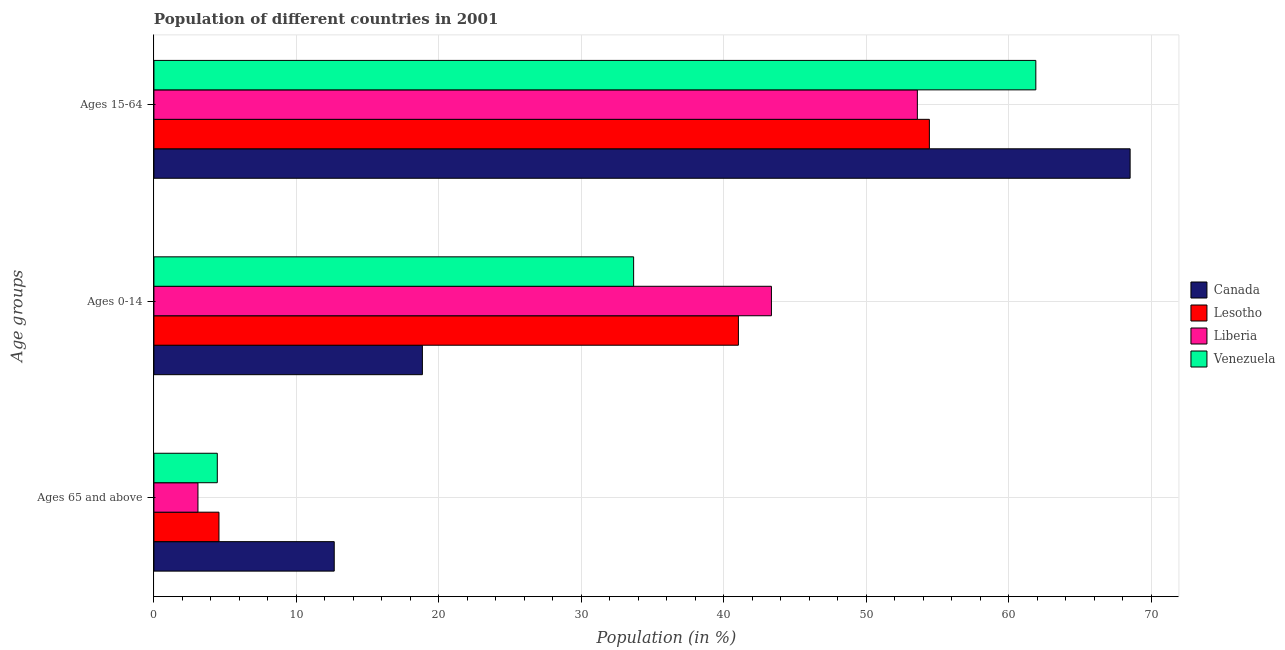Are the number of bars on each tick of the Y-axis equal?
Provide a short and direct response. Yes. How many bars are there on the 3rd tick from the top?
Provide a succinct answer. 4. What is the label of the 2nd group of bars from the top?
Your response must be concise. Ages 0-14. What is the percentage of population within the age-group 15-64 in Lesotho?
Provide a short and direct response. 54.42. Across all countries, what is the maximum percentage of population within the age-group 15-64?
Your answer should be compact. 68.51. Across all countries, what is the minimum percentage of population within the age-group of 65 and above?
Your answer should be compact. 3.09. In which country was the percentage of population within the age-group 15-64 minimum?
Ensure brevity in your answer.  Liberia. What is the total percentage of population within the age-group 0-14 in the graph?
Make the answer very short. 136.85. What is the difference between the percentage of population within the age-group 15-64 in Lesotho and that in Canada?
Your answer should be compact. -14.09. What is the difference between the percentage of population within the age-group 0-14 in Liberia and the percentage of population within the age-group of 65 and above in Venezuela?
Ensure brevity in your answer.  38.89. What is the average percentage of population within the age-group 15-64 per country?
Your answer should be very brief. 59.6. What is the difference between the percentage of population within the age-group of 65 and above and percentage of population within the age-group 0-14 in Liberia?
Provide a short and direct response. -40.24. In how many countries, is the percentage of population within the age-group 0-14 greater than 46 %?
Provide a succinct answer. 0. What is the ratio of the percentage of population within the age-group of 65 and above in Liberia to that in Lesotho?
Offer a terse response. 0.68. Is the percentage of population within the age-group 15-64 in Venezuela less than that in Lesotho?
Offer a very short reply. No. Is the difference between the percentage of population within the age-group of 65 and above in Canada and Venezuela greater than the difference between the percentage of population within the age-group 0-14 in Canada and Venezuela?
Offer a terse response. Yes. What is the difference between the highest and the second highest percentage of population within the age-group 15-64?
Make the answer very short. 6.62. What is the difference between the highest and the lowest percentage of population within the age-group 15-64?
Your answer should be very brief. 14.93. In how many countries, is the percentage of population within the age-group 0-14 greater than the average percentage of population within the age-group 0-14 taken over all countries?
Provide a succinct answer. 2. Is the sum of the percentage of population within the age-group 15-64 in Lesotho and Venezuela greater than the maximum percentage of population within the age-group 0-14 across all countries?
Ensure brevity in your answer.  Yes. What does the 1st bar from the top in Ages 0-14 represents?
Keep it short and to the point. Venezuela. What does the 1st bar from the bottom in Ages 0-14 represents?
Your answer should be compact. Canada. Is it the case that in every country, the sum of the percentage of population within the age-group of 65 and above and percentage of population within the age-group 0-14 is greater than the percentage of population within the age-group 15-64?
Offer a terse response. No. Are all the bars in the graph horizontal?
Your answer should be compact. Yes. What is the difference between two consecutive major ticks on the X-axis?
Offer a terse response. 10. Does the graph contain any zero values?
Ensure brevity in your answer.  No. How are the legend labels stacked?
Ensure brevity in your answer.  Vertical. What is the title of the graph?
Give a very brief answer. Population of different countries in 2001. What is the label or title of the Y-axis?
Make the answer very short. Age groups. What is the Population (in %) of Canada in Ages 65 and above?
Keep it short and to the point. 12.65. What is the Population (in %) of Lesotho in Ages 65 and above?
Offer a terse response. 4.56. What is the Population (in %) in Liberia in Ages 65 and above?
Your answer should be compact. 3.09. What is the Population (in %) in Venezuela in Ages 65 and above?
Your answer should be compact. 4.45. What is the Population (in %) in Canada in Ages 0-14?
Offer a very short reply. 18.84. What is the Population (in %) in Lesotho in Ages 0-14?
Your answer should be very brief. 41.02. What is the Population (in %) of Liberia in Ages 0-14?
Keep it short and to the point. 43.33. What is the Population (in %) of Venezuela in Ages 0-14?
Provide a succinct answer. 33.66. What is the Population (in %) in Canada in Ages 15-64?
Your response must be concise. 68.51. What is the Population (in %) of Lesotho in Ages 15-64?
Your answer should be compact. 54.42. What is the Population (in %) in Liberia in Ages 15-64?
Your answer should be very brief. 53.58. What is the Population (in %) in Venezuela in Ages 15-64?
Your answer should be compact. 61.89. Across all Age groups, what is the maximum Population (in %) of Canada?
Provide a succinct answer. 68.51. Across all Age groups, what is the maximum Population (in %) of Lesotho?
Ensure brevity in your answer.  54.42. Across all Age groups, what is the maximum Population (in %) in Liberia?
Give a very brief answer. 53.58. Across all Age groups, what is the maximum Population (in %) of Venezuela?
Your answer should be compact. 61.89. Across all Age groups, what is the minimum Population (in %) of Canada?
Offer a very short reply. 12.65. Across all Age groups, what is the minimum Population (in %) in Lesotho?
Give a very brief answer. 4.56. Across all Age groups, what is the minimum Population (in %) of Liberia?
Offer a very short reply. 3.09. Across all Age groups, what is the minimum Population (in %) in Venezuela?
Offer a very short reply. 4.45. What is the total Population (in %) in Canada in the graph?
Ensure brevity in your answer.  100. What is the total Population (in %) of Lesotho in the graph?
Your answer should be compact. 100. What is the total Population (in %) of Liberia in the graph?
Your answer should be very brief. 100. What is the total Population (in %) of Venezuela in the graph?
Offer a terse response. 100. What is the difference between the Population (in %) of Canada in Ages 65 and above and that in Ages 0-14?
Make the answer very short. -6.19. What is the difference between the Population (in %) of Lesotho in Ages 65 and above and that in Ages 0-14?
Offer a very short reply. -36.45. What is the difference between the Population (in %) in Liberia in Ages 65 and above and that in Ages 0-14?
Your answer should be very brief. -40.24. What is the difference between the Population (in %) of Venezuela in Ages 65 and above and that in Ages 0-14?
Provide a succinct answer. -29.22. What is the difference between the Population (in %) of Canada in Ages 65 and above and that in Ages 15-64?
Make the answer very short. -55.85. What is the difference between the Population (in %) of Lesotho in Ages 65 and above and that in Ages 15-64?
Give a very brief answer. -49.85. What is the difference between the Population (in %) in Liberia in Ages 65 and above and that in Ages 15-64?
Provide a succinct answer. -50.49. What is the difference between the Population (in %) of Venezuela in Ages 65 and above and that in Ages 15-64?
Give a very brief answer. -57.44. What is the difference between the Population (in %) in Canada in Ages 0-14 and that in Ages 15-64?
Ensure brevity in your answer.  -49.67. What is the difference between the Population (in %) in Lesotho in Ages 0-14 and that in Ages 15-64?
Your answer should be very brief. -13.4. What is the difference between the Population (in %) of Liberia in Ages 0-14 and that in Ages 15-64?
Your answer should be compact. -10.24. What is the difference between the Population (in %) in Venezuela in Ages 0-14 and that in Ages 15-64?
Your answer should be very brief. -28.23. What is the difference between the Population (in %) in Canada in Ages 65 and above and the Population (in %) in Lesotho in Ages 0-14?
Your answer should be very brief. -28.36. What is the difference between the Population (in %) of Canada in Ages 65 and above and the Population (in %) of Liberia in Ages 0-14?
Your answer should be very brief. -30.68. What is the difference between the Population (in %) in Canada in Ages 65 and above and the Population (in %) in Venezuela in Ages 0-14?
Give a very brief answer. -21.01. What is the difference between the Population (in %) in Lesotho in Ages 65 and above and the Population (in %) in Liberia in Ages 0-14?
Offer a terse response. -38.77. What is the difference between the Population (in %) in Lesotho in Ages 65 and above and the Population (in %) in Venezuela in Ages 0-14?
Provide a short and direct response. -29.1. What is the difference between the Population (in %) in Liberia in Ages 65 and above and the Population (in %) in Venezuela in Ages 0-14?
Provide a succinct answer. -30.57. What is the difference between the Population (in %) in Canada in Ages 65 and above and the Population (in %) in Lesotho in Ages 15-64?
Your answer should be compact. -41.77. What is the difference between the Population (in %) in Canada in Ages 65 and above and the Population (in %) in Liberia in Ages 15-64?
Provide a short and direct response. -40.92. What is the difference between the Population (in %) in Canada in Ages 65 and above and the Population (in %) in Venezuela in Ages 15-64?
Your answer should be compact. -49.24. What is the difference between the Population (in %) of Lesotho in Ages 65 and above and the Population (in %) of Liberia in Ages 15-64?
Ensure brevity in your answer.  -49.01. What is the difference between the Population (in %) of Lesotho in Ages 65 and above and the Population (in %) of Venezuela in Ages 15-64?
Give a very brief answer. -57.33. What is the difference between the Population (in %) of Liberia in Ages 65 and above and the Population (in %) of Venezuela in Ages 15-64?
Ensure brevity in your answer.  -58.8. What is the difference between the Population (in %) of Canada in Ages 0-14 and the Population (in %) of Lesotho in Ages 15-64?
Keep it short and to the point. -35.58. What is the difference between the Population (in %) in Canada in Ages 0-14 and the Population (in %) in Liberia in Ages 15-64?
Your response must be concise. -34.74. What is the difference between the Population (in %) in Canada in Ages 0-14 and the Population (in %) in Venezuela in Ages 15-64?
Make the answer very short. -43.05. What is the difference between the Population (in %) of Lesotho in Ages 0-14 and the Population (in %) of Liberia in Ages 15-64?
Your answer should be very brief. -12.56. What is the difference between the Population (in %) of Lesotho in Ages 0-14 and the Population (in %) of Venezuela in Ages 15-64?
Provide a short and direct response. -20.87. What is the difference between the Population (in %) in Liberia in Ages 0-14 and the Population (in %) in Venezuela in Ages 15-64?
Provide a short and direct response. -18.56. What is the average Population (in %) in Canada per Age groups?
Your response must be concise. 33.33. What is the average Population (in %) in Lesotho per Age groups?
Provide a succinct answer. 33.33. What is the average Population (in %) of Liberia per Age groups?
Keep it short and to the point. 33.33. What is the average Population (in %) in Venezuela per Age groups?
Make the answer very short. 33.33. What is the difference between the Population (in %) of Canada and Population (in %) of Lesotho in Ages 65 and above?
Offer a terse response. 8.09. What is the difference between the Population (in %) of Canada and Population (in %) of Liberia in Ages 65 and above?
Provide a short and direct response. 9.56. What is the difference between the Population (in %) in Canada and Population (in %) in Venezuela in Ages 65 and above?
Ensure brevity in your answer.  8.21. What is the difference between the Population (in %) in Lesotho and Population (in %) in Liberia in Ages 65 and above?
Ensure brevity in your answer.  1.47. What is the difference between the Population (in %) of Lesotho and Population (in %) of Venezuela in Ages 65 and above?
Make the answer very short. 0.12. What is the difference between the Population (in %) in Liberia and Population (in %) in Venezuela in Ages 65 and above?
Provide a short and direct response. -1.36. What is the difference between the Population (in %) in Canada and Population (in %) in Lesotho in Ages 0-14?
Your response must be concise. -22.18. What is the difference between the Population (in %) of Canada and Population (in %) of Liberia in Ages 0-14?
Your response must be concise. -24.49. What is the difference between the Population (in %) in Canada and Population (in %) in Venezuela in Ages 0-14?
Offer a terse response. -14.82. What is the difference between the Population (in %) of Lesotho and Population (in %) of Liberia in Ages 0-14?
Your answer should be compact. -2.32. What is the difference between the Population (in %) in Lesotho and Population (in %) in Venezuela in Ages 0-14?
Offer a terse response. 7.35. What is the difference between the Population (in %) of Liberia and Population (in %) of Venezuela in Ages 0-14?
Offer a very short reply. 9.67. What is the difference between the Population (in %) of Canada and Population (in %) of Lesotho in Ages 15-64?
Give a very brief answer. 14.09. What is the difference between the Population (in %) in Canada and Population (in %) in Liberia in Ages 15-64?
Provide a succinct answer. 14.93. What is the difference between the Population (in %) of Canada and Population (in %) of Venezuela in Ages 15-64?
Your answer should be compact. 6.62. What is the difference between the Population (in %) of Lesotho and Population (in %) of Liberia in Ages 15-64?
Offer a terse response. 0.84. What is the difference between the Population (in %) of Lesotho and Population (in %) of Venezuela in Ages 15-64?
Offer a very short reply. -7.47. What is the difference between the Population (in %) of Liberia and Population (in %) of Venezuela in Ages 15-64?
Give a very brief answer. -8.31. What is the ratio of the Population (in %) of Canada in Ages 65 and above to that in Ages 0-14?
Give a very brief answer. 0.67. What is the ratio of the Population (in %) in Lesotho in Ages 65 and above to that in Ages 0-14?
Your answer should be very brief. 0.11. What is the ratio of the Population (in %) of Liberia in Ages 65 and above to that in Ages 0-14?
Ensure brevity in your answer.  0.07. What is the ratio of the Population (in %) of Venezuela in Ages 65 and above to that in Ages 0-14?
Provide a succinct answer. 0.13. What is the ratio of the Population (in %) in Canada in Ages 65 and above to that in Ages 15-64?
Offer a very short reply. 0.18. What is the ratio of the Population (in %) in Lesotho in Ages 65 and above to that in Ages 15-64?
Give a very brief answer. 0.08. What is the ratio of the Population (in %) in Liberia in Ages 65 and above to that in Ages 15-64?
Make the answer very short. 0.06. What is the ratio of the Population (in %) in Venezuela in Ages 65 and above to that in Ages 15-64?
Keep it short and to the point. 0.07. What is the ratio of the Population (in %) of Canada in Ages 0-14 to that in Ages 15-64?
Provide a short and direct response. 0.28. What is the ratio of the Population (in %) of Lesotho in Ages 0-14 to that in Ages 15-64?
Give a very brief answer. 0.75. What is the ratio of the Population (in %) of Liberia in Ages 0-14 to that in Ages 15-64?
Your answer should be compact. 0.81. What is the ratio of the Population (in %) in Venezuela in Ages 0-14 to that in Ages 15-64?
Make the answer very short. 0.54. What is the difference between the highest and the second highest Population (in %) in Canada?
Give a very brief answer. 49.67. What is the difference between the highest and the second highest Population (in %) in Lesotho?
Ensure brevity in your answer.  13.4. What is the difference between the highest and the second highest Population (in %) of Liberia?
Your answer should be compact. 10.24. What is the difference between the highest and the second highest Population (in %) of Venezuela?
Keep it short and to the point. 28.23. What is the difference between the highest and the lowest Population (in %) of Canada?
Keep it short and to the point. 55.85. What is the difference between the highest and the lowest Population (in %) of Lesotho?
Make the answer very short. 49.85. What is the difference between the highest and the lowest Population (in %) of Liberia?
Give a very brief answer. 50.49. What is the difference between the highest and the lowest Population (in %) of Venezuela?
Your response must be concise. 57.44. 